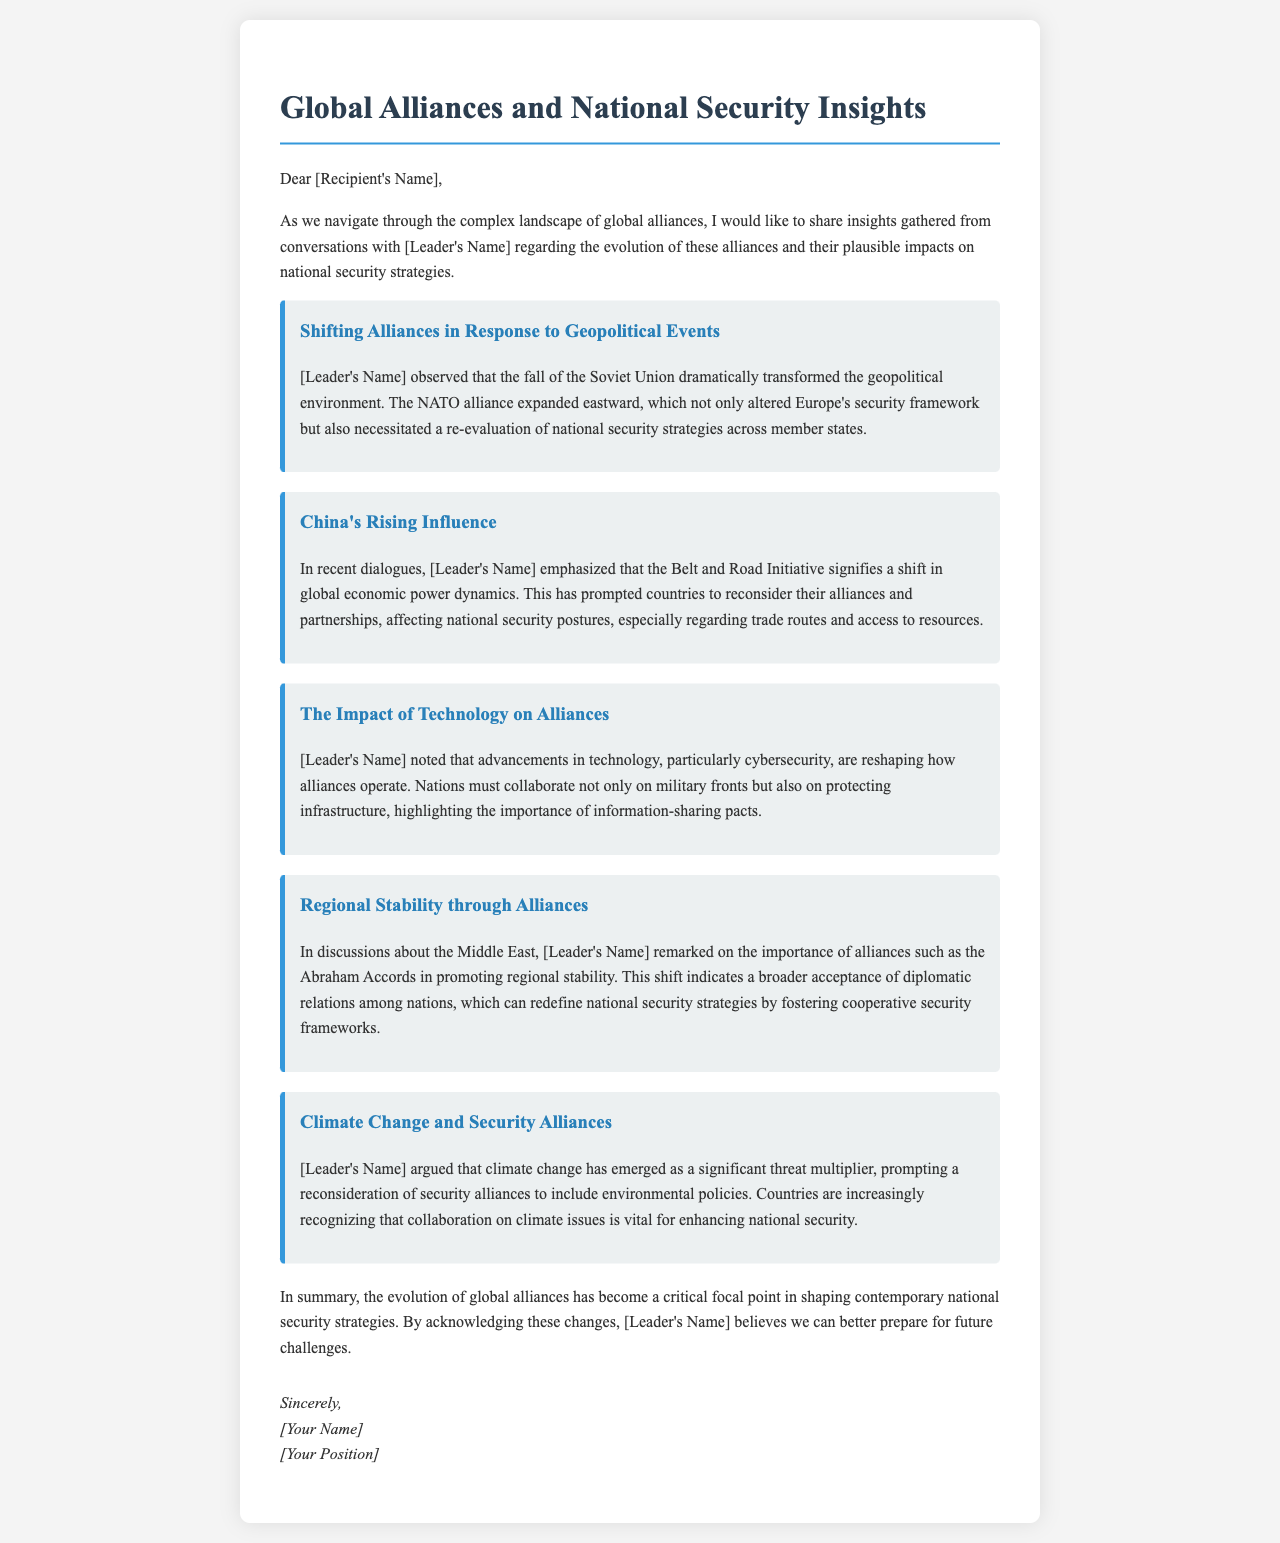What significant geopolitical event transformed the landscape of global alliances? The fall of the Soviet Union dramatically transformed the geopolitical environment.
Answer: fall of the Soviet Union What initiative did China implement that signifies a shift in global economic power dynamics? The Belt and Road Initiative signifies a shift in global economic power dynamics.
Answer: Belt and Road Initiative Which cybersecurity aspect is crucial for nations in the context of alliances? Nations must collaborate on protecting infrastructure.
Answer: protecting infrastructure What was remarked upon regarding the Abraham Accords? The importance of alliances such as the Abraham Accords in promoting regional stability was noted.
Answer: regional stability What emerging threat has prompted a reconsideration of security alliances, according to the leader? Climate change has emerged as a significant threat multiplier.
Answer: climate change Who is the author of the insights shared in the document? The insights were gathered from conversations with the leader.
Answer: [Leader's Name] What type of document is this? This document is a letter sharing insights on global alliances and national security.
Answer: letter What emphasizes the importance of information-sharing in the context of alliances? Advancements in technology, particularly cybersecurity, are reshaping how alliances operate.
Answer: cybersecurity 